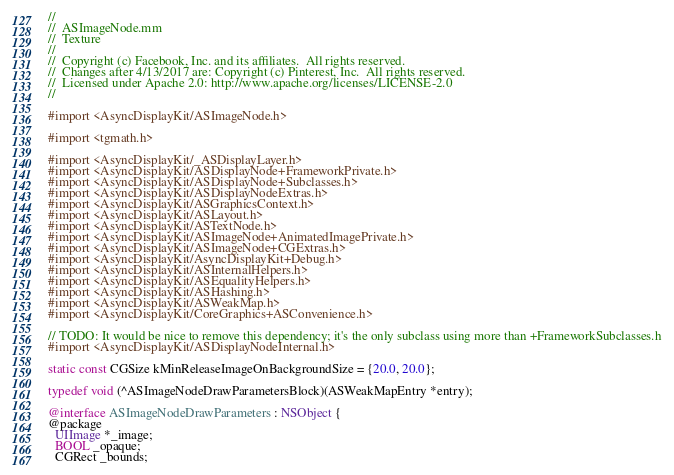Convert code to text. <code><loc_0><loc_0><loc_500><loc_500><_ObjectiveC_>//
//  ASImageNode.mm
//  Texture
//
//  Copyright (c) Facebook, Inc. and its affiliates.  All rights reserved.
//  Changes after 4/13/2017 are: Copyright (c) Pinterest, Inc.  All rights reserved.
//  Licensed under Apache 2.0: http://www.apache.org/licenses/LICENSE-2.0
//

#import <AsyncDisplayKit/ASImageNode.h>

#import <tgmath.h>

#import <AsyncDisplayKit/_ASDisplayLayer.h>
#import <AsyncDisplayKit/ASDisplayNode+FrameworkPrivate.h>
#import <AsyncDisplayKit/ASDisplayNode+Subclasses.h>
#import <AsyncDisplayKit/ASDisplayNodeExtras.h>
#import <AsyncDisplayKit/ASGraphicsContext.h>
#import <AsyncDisplayKit/ASLayout.h>
#import <AsyncDisplayKit/ASTextNode.h>
#import <AsyncDisplayKit/ASImageNode+AnimatedImagePrivate.h>
#import <AsyncDisplayKit/ASImageNode+CGExtras.h>
#import <AsyncDisplayKit/AsyncDisplayKit+Debug.h>
#import <AsyncDisplayKit/ASInternalHelpers.h>
#import <AsyncDisplayKit/ASEqualityHelpers.h>
#import <AsyncDisplayKit/ASHashing.h>
#import <AsyncDisplayKit/ASWeakMap.h>
#import <AsyncDisplayKit/CoreGraphics+ASConvenience.h>

// TODO: It would be nice to remove this dependency; it's the only subclass using more than +FrameworkSubclasses.h
#import <AsyncDisplayKit/ASDisplayNodeInternal.h>

static const CGSize kMinReleaseImageOnBackgroundSize = {20.0, 20.0};

typedef void (^ASImageNodeDrawParametersBlock)(ASWeakMapEntry *entry);

@interface ASImageNodeDrawParameters : NSObject {
@package
  UIImage *_image;
  BOOL _opaque;
  CGRect _bounds;</code> 